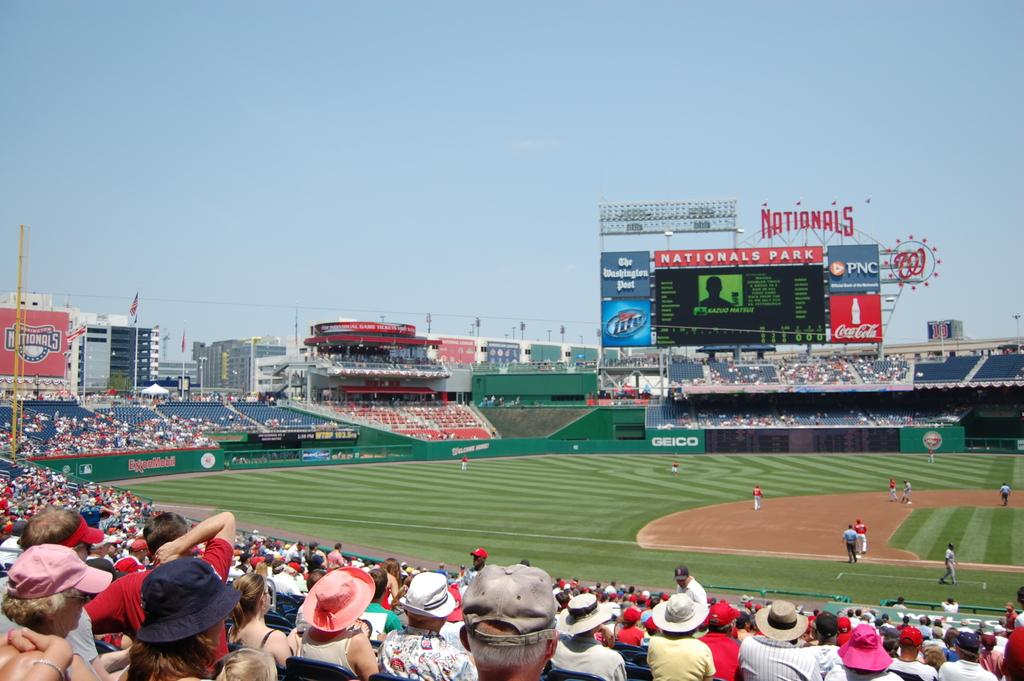<image>
Present a compact description of the photo's key features. Nationals Park is having a baseball game and the stadium is filled with people. 